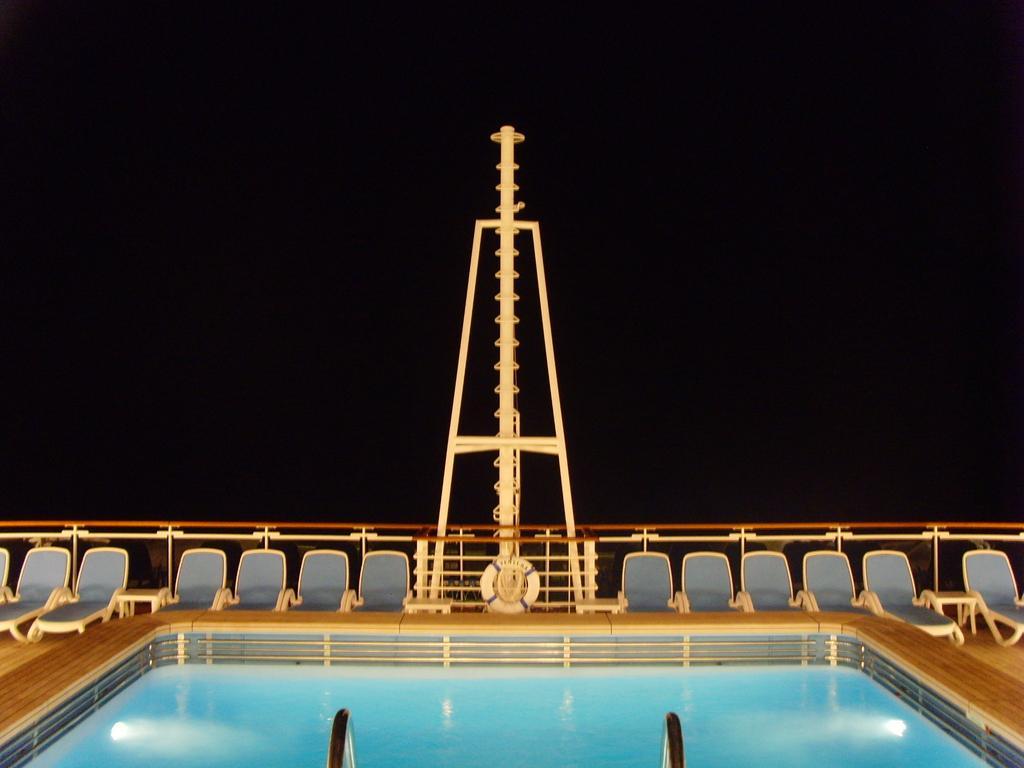Can you describe this image briefly? In this image we can see a swimming pool. In the center there is a pole and we can see chaise loungers. There is a railing. 